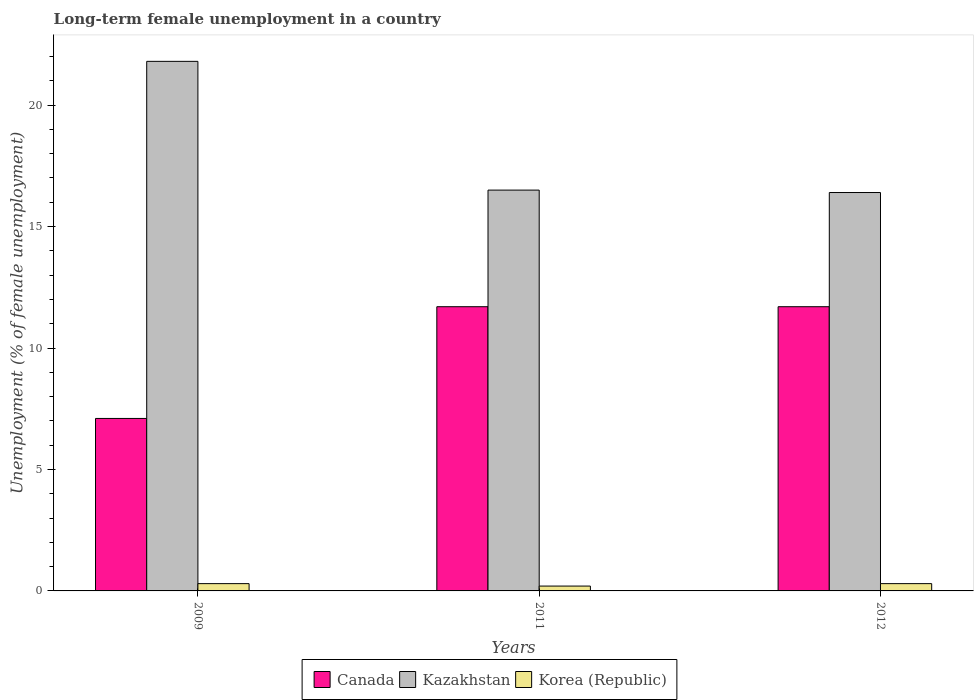How many different coloured bars are there?
Give a very brief answer. 3. How many groups of bars are there?
Offer a terse response. 3. Are the number of bars per tick equal to the number of legend labels?
Offer a terse response. Yes. How many bars are there on the 1st tick from the left?
Give a very brief answer. 3. How many bars are there on the 2nd tick from the right?
Make the answer very short. 3. What is the percentage of long-term unemployed female population in Canada in 2012?
Provide a succinct answer. 11.7. Across all years, what is the maximum percentage of long-term unemployed female population in Canada?
Ensure brevity in your answer.  11.7. Across all years, what is the minimum percentage of long-term unemployed female population in Korea (Republic)?
Ensure brevity in your answer.  0.2. What is the total percentage of long-term unemployed female population in Korea (Republic) in the graph?
Provide a short and direct response. 0.8. What is the difference between the percentage of long-term unemployed female population in Kazakhstan in 2009 and that in 2012?
Offer a terse response. 5.4. What is the difference between the percentage of long-term unemployed female population in Canada in 2011 and the percentage of long-term unemployed female population in Kazakhstan in 2012?
Provide a short and direct response. -4.7. What is the average percentage of long-term unemployed female population in Kazakhstan per year?
Provide a succinct answer. 18.23. In the year 2009, what is the difference between the percentage of long-term unemployed female population in Canada and percentage of long-term unemployed female population in Korea (Republic)?
Your answer should be very brief. 6.8. In how many years, is the percentage of long-term unemployed female population in Korea (Republic) greater than 18 %?
Give a very brief answer. 0. What is the ratio of the percentage of long-term unemployed female population in Kazakhstan in 2009 to that in 2011?
Offer a terse response. 1.32. Is the percentage of long-term unemployed female population in Korea (Republic) in 2009 less than that in 2011?
Your answer should be very brief. No. What is the difference between the highest and the second highest percentage of long-term unemployed female population in Korea (Republic)?
Offer a very short reply. 0. What is the difference between the highest and the lowest percentage of long-term unemployed female population in Kazakhstan?
Provide a succinct answer. 5.4. In how many years, is the percentage of long-term unemployed female population in Canada greater than the average percentage of long-term unemployed female population in Canada taken over all years?
Ensure brevity in your answer.  2. What does the 2nd bar from the right in 2009 represents?
Ensure brevity in your answer.  Kazakhstan. What is the difference between two consecutive major ticks on the Y-axis?
Keep it short and to the point. 5. Does the graph contain any zero values?
Make the answer very short. No. Does the graph contain grids?
Make the answer very short. No. What is the title of the graph?
Offer a very short reply. Long-term female unemployment in a country. What is the label or title of the Y-axis?
Give a very brief answer. Unemployment (% of female unemployment). What is the Unemployment (% of female unemployment) of Canada in 2009?
Your answer should be very brief. 7.1. What is the Unemployment (% of female unemployment) in Kazakhstan in 2009?
Your answer should be very brief. 21.8. What is the Unemployment (% of female unemployment) in Korea (Republic) in 2009?
Your answer should be very brief. 0.3. What is the Unemployment (% of female unemployment) of Canada in 2011?
Provide a short and direct response. 11.7. What is the Unemployment (% of female unemployment) of Korea (Republic) in 2011?
Give a very brief answer. 0.2. What is the Unemployment (% of female unemployment) of Canada in 2012?
Provide a short and direct response. 11.7. What is the Unemployment (% of female unemployment) in Kazakhstan in 2012?
Give a very brief answer. 16.4. What is the Unemployment (% of female unemployment) in Korea (Republic) in 2012?
Offer a terse response. 0.3. Across all years, what is the maximum Unemployment (% of female unemployment) of Canada?
Provide a short and direct response. 11.7. Across all years, what is the maximum Unemployment (% of female unemployment) of Kazakhstan?
Your answer should be compact. 21.8. Across all years, what is the maximum Unemployment (% of female unemployment) of Korea (Republic)?
Provide a short and direct response. 0.3. Across all years, what is the minimum Unemployment (% of female unemployment) in Canada?
Ensure brevity in your answer.  7.1. Across all years, what is the minimum Unemployment (% of female unemployment) of Kazakhstan?
Your response must be concise. 16.4. Across all years, what is the minimum Unemployment (% of female unemployment) in Korea (Republic)?
Give a very brief answer. 0.2. What is the total Unemployment (% of female unemployment) of Canada in the graph?
Offer a very short reply. 30.5. What is the total Unemployment (% of female unemployment) of Kazakhstan in the graph?
Your answer should be very brief. 54.7. What is the difference between the Unemployment (% of female unemployment) in Canada in 2009 and that in 2011?
Provide a short and direct response. -4.6. What is the difference between the Unemployment (% of female unemployment) in Korea (Republic) in 2009 and that in 2011?
Ensure brevity in your answer.  0.1. What is the difference between the Unemployment (% of female unemployment) in Kazakhstan in 2009 and that in 2012?
Give a very brief answer. 5.4. What is the difference between the Unemployment (% of female unemployment) of Korea (Republic) in 2011 and that in 2012?
Your answer should be very brief. -0.1. What is the difference between the Unemployment (% of female unemployment) in Kazakhstan in 2009 and the Unemployment (% of female unemployment) in Korea (Republic) in 2011?
Your answer should be very brief. 21.6. What is the difference between the Unemployment (% of female unemployment) of Canada in 2009 and the Unemployment (% of female unemployment) of Kazakhstan in 2012?
Give a very brief answer. -9.3. What is the difference between the Unemployment (% of female unemployment) in Kazakhstan in 2009 and the Unemployment (% of female unemployment) in Korea (Republic) in 2012?
Your response must be concise. 21.5. What is the difference between the Unemployment (% of female unemployment) in Canada in 2011 and the Unemployment (% of female unemployment) in Kazakhstan in 2012?
Ensure brevity in your answer.  -4.7. What is the difference between the Unemployment (% of female unemployment) of Canada in 2011 and the Unemployment (% of female unemployment) of Korea (Republic) in 2012?
Your answer should be very brief. 11.4. What is the average Unemployment (% of female unemployment) in Canada per year?
Ensure brevity in your answer.  10.17. What is the average Unemployment (% of female unemployment) in Kazakhstan per year?
Ensure brevity in your answer.  18.23. What is the average Unemployment (% of female unemployment) in Korea (Republic) per year?
Offer a very short reply. 0.27. In the year 2009, what is the difference between the Unemployment (% of female unemployment) of Canada and Unemployment (% of female unemployment) of Kazakhstan?
Give a very brief answer. -14.7. In the year 2009, what is the difference between the Unemployment (% of female unemployment) in Canada and Unemployment (% of female unemployment) in Korea (Republic)?
Make the answer very short. 6.8. In the year 2011, what is the difference between the Unemployment (% of female unemployment) in Canada and Unemployment (% of female unemployment) in Kazakhstan?
Your response must be concise. -4.8. In the year 2012, what is the difference between the Unemployment (% of female unemployment) in Canada and Unemployment (% of female unemployment) in Kazakhstan?
Offer a terse response. -4.7. In the year 2012, what is the difference between the Unemployment (% of female unemployment) in Kazakhstan and Unemployment (% of female unemployment) in Korea (Republic)?
Give a very brief answer. 16.1. What is the ratio of the Unemployment (% of female unemployment) in Canada in 2009 to that in 2011?
Offer a very short reply. 0.61. What is the ratio of the Unemployment (% of female unemployment) of Kazakhstan in 2009 to that in 2011?
Give a very brief answer. 1.32. What is the ratio of the Unemployment (% of female unemployment) in Canada in 2009 to that in 2012?
Make the answer very short. 0.61. What is the ratio of the Unemployment (% of female unemployment) in Kazakhstan in 2009 to that in 2012?
Ensure brevity in your answer.  1.33. What is the ratio of the Unemployment (% of female unemployment) in Canada in 2011 to that in 2012?
Your answer should be very brief. 1. What is the ratio of the Unemployment (% of female unemployment) in Kazakhstan in 2011 to that in 2012?
Provide a short and direct response. 1.01. What is the difference between the highest and the second highest Unemployment (% of female unemployment) in Korea (Republic)?
Keep it short and to the point. 0. What is the difference between the highest and the lowest Unemployment (% of female unemployment) in Korea (Republic)?
Provide a succinct answer. 0.1. 